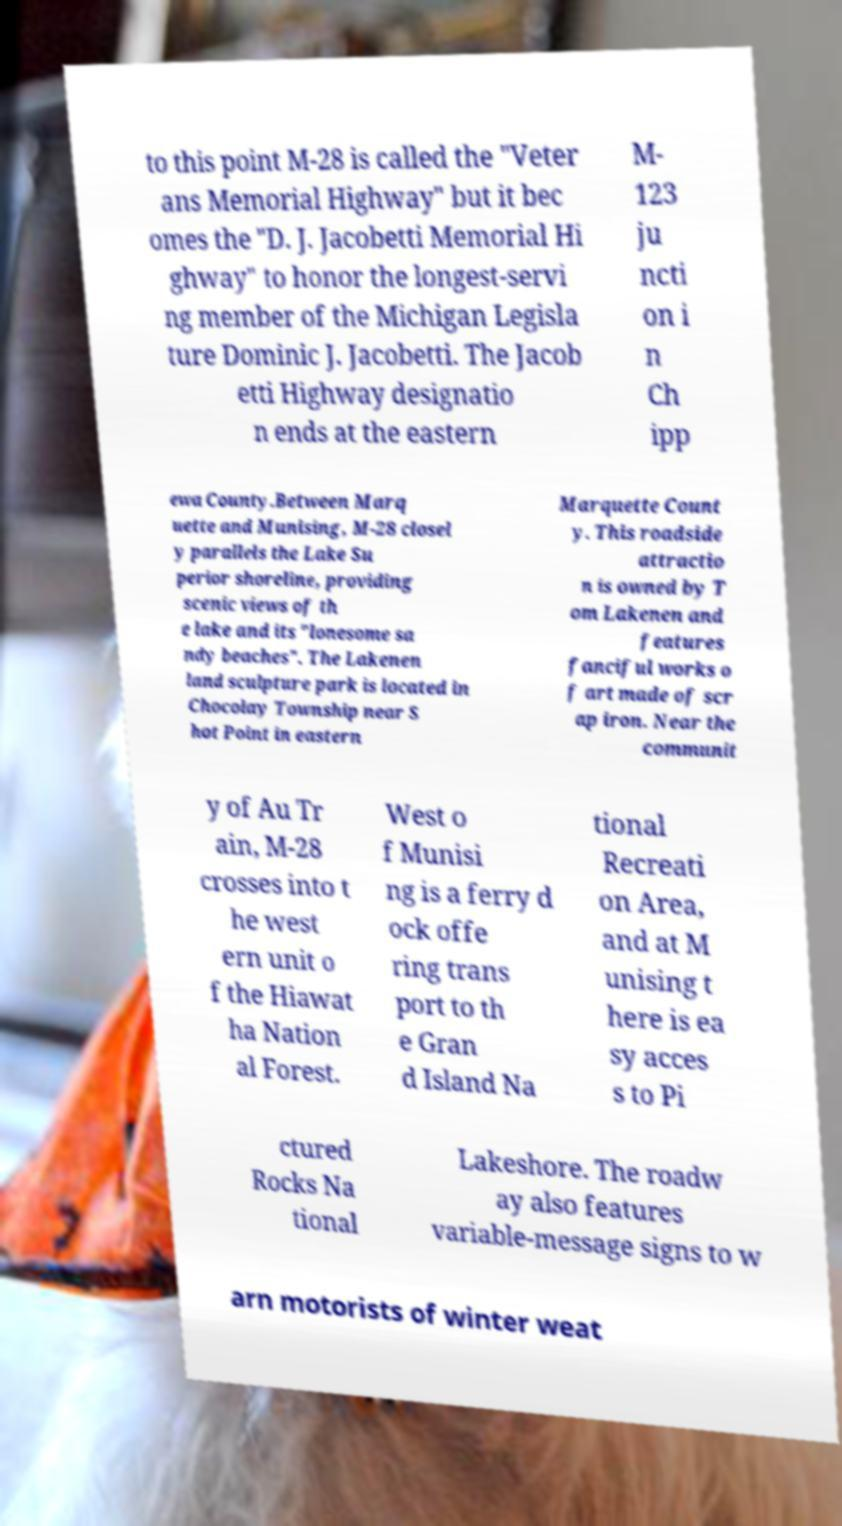Please identify and transcribe the text found in this image. to this point M-28 is called the "Veter ans Memorial Highway" but it bec omes the "D. J. Jacobetti Memorial Hi ghway" to honor the longest-servi ng member of the Michigan Legisla ture Dominic J. Jacobetti. The Jacob etti Highway designatio n ends at the eastern M- 123 ju ncti on i n Ch ipp ewa County.Between Marq uette and Munising, M-28 closel y parallels the Lake Su perior shoreline, providing scenic views of th e lake and its "lonesome sa ndy beaches". The Lakenen land sculpture park is located in Chocolay Township near S hot Point in eastern Marquette Count y. This roadside attractio n is owned by T om Lakenen and features fanciful works o f art made of scr ap iron. Near the communit y of Au Tr ain, M-28 crosses into t he west ern unit o f the Hiawat ha Nation al Forest. West o f Munisi ng is a ferry d ock offe ring trans port to th e Gran d Island Na tional Recreati on Area, and at M unising t here is ea sy acces s to Pi ctured Rocks Na tional Lakeshore. The roadw ay also features variable-message signs to w arn motorists of winter weat 